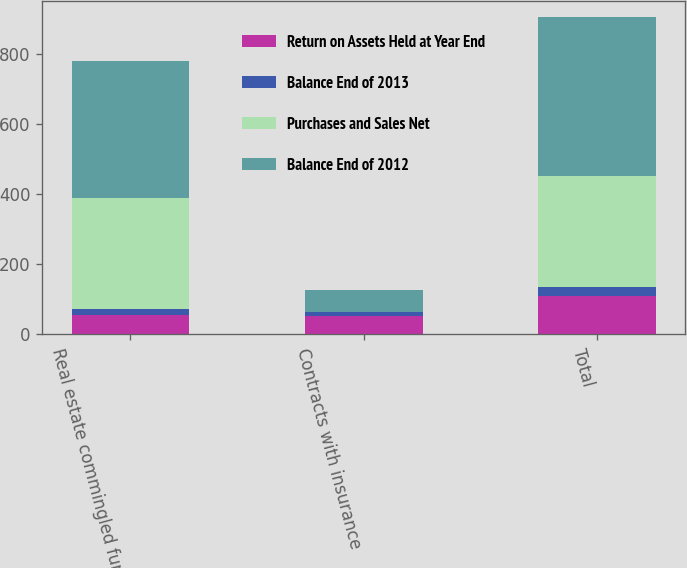Convert chart to OTSL. <chart><loc_0><loc_0><loc_500><loc_500><stacked_bar_chart><ecel><fcel>Real estate commingled funds<fcel>Contracts with insurance<fcel>Total<nl><fcel>Return on Assets Held at Year End<fcel>56<fcel>54<fcel>110<nl><fcel>Balance End of 2013<fcel>16<fcel>9<fcel>25<nl><fcel>Purchases and Sales Net<fcel>319<fcel>1<fcel>318<nl><fcel>Balance End of 2012<fcel>391<fcel>62<fcel>453<nl></chart> 